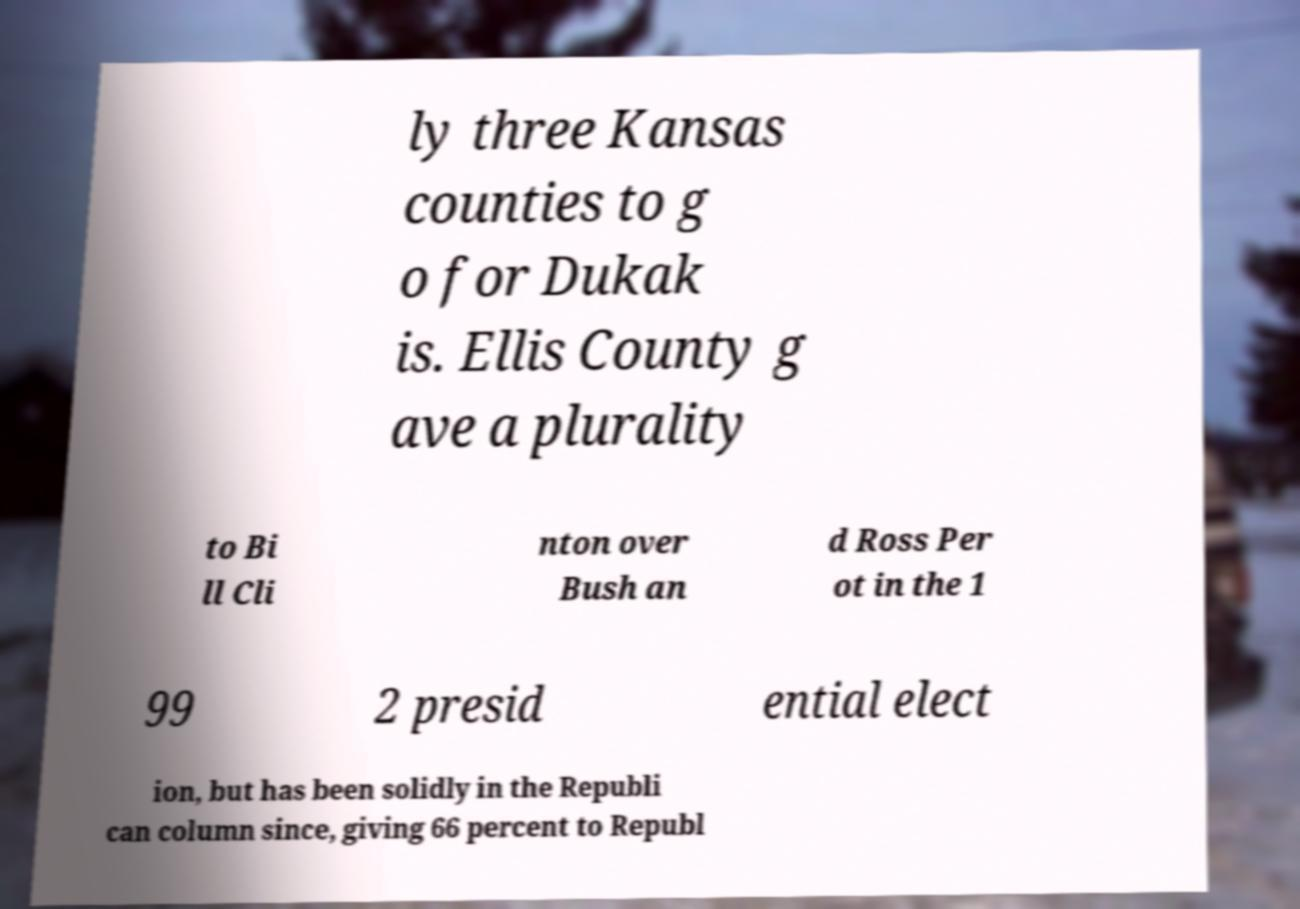What messages or text are displayed in this image? I need them in a readable, typed format. ly three Kansas counties to g o for Dukak is. Ellis County g ave a plurality to Bi ll Cli nton over Bush an d Ross Per ot in the 1 99 2 presid ential elect ion, but has been solidly in the Republi can column since, giving 66 percent to Republ 